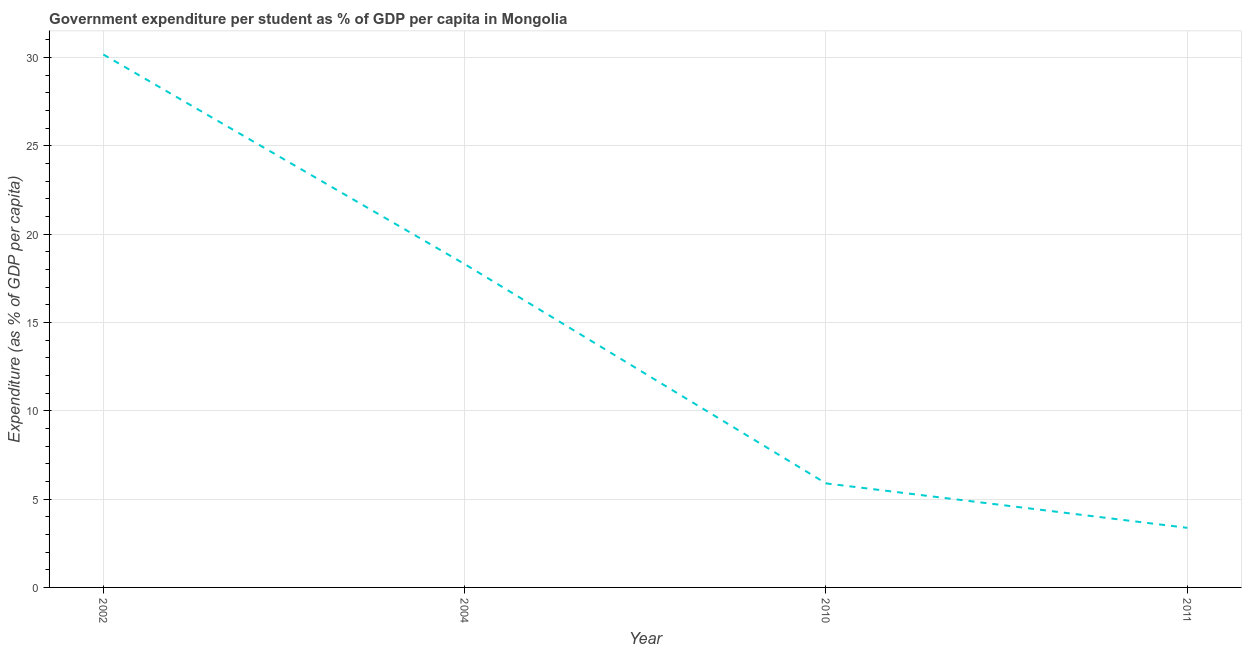What is the government expenditure per student in 2002?
Your answer should be very brief. 30.17. Across all years, what is the maximum government expenditure per student?
Offer a terse response. 30.17. Across all years, what is the minimum government expenditure per student?
Your answer should be very brief. 3.37. In which year was the government expenditure per student minimum?
Keep it short and to the point. 2011. What is the sum of the government expenditure per student?
Offer a terse response. 57.74. What is the difference between the government expenditure per student in 2002 and 2004?
Your answer should be very brief. 11.86. What is the average government expenditure per student per year?
Make the answer very short. 14.43. What is the median government expenditure per student?
Make the answer very short. 12.1. In how many years, is the government expenditure per student greater than 4 %?
Provide a short and direct response. 3. What is the ratio of the government expenditure per student in 2002 to that in 2004?
Offer a very short reply. 1.65. Is the government expenditure per student in 2002 less than that in 2011?
Your answer should be compact. No. Is the difference between the government expenditure per student in 2010 and 2011 greater than the difference between any two years?
Offer a terse response. No. What is the difference between the highest and the second highest government expenditure per student?
Provide a short and direct response. 11.86. What is the difference between the highest and the lowest government expenditure per student?
Offer a very short reply. 26.8. In how many years, is the government expenditure per student greater than the average government expenditure per student taken over all years?
Provide a succinct answer. 2. What is the difference between two consecutive major ticks on the Y-axis?
Provide a succinct answer. 5. Are the values on the major ticks of Y-axis written in scientific E-notation?
Give a very brief answer. No. What is the title of the graph?
Ensure brevity in your answer.  Government expenditure per student as % of GDP per capita in Mongolia. What is the label or title of the X-axis?
Provide a succinct answer. Year. What is the label or title of the Y-axis?
Give a very brief answer. Expenditure (as % of GDP per capita). What is the Expenditure (as % of GDP per capita) of 2002?
Offer a terse response. 30.17. What is the Expenditure (as % of GDP per capita) in 2004?
Your answer should be compact. 18.3. What is the Expenditure (as % of GDP per capita) of 2010?
Your response must be concise. 5.89. What is the Expenditure (as % of GDP per capita) of 2011?
Your answer should be compact. 3.37. What is the difference between the Expenditure (as % of GDP per capita) in 2002 and 2004?
Offer a terse response. 11.86. What is the difference between the Expenditure (as % of GDP per capita) in 2002 and 2010?
Make the answer very short. 24.28. What is the difference between the Expenditure (as % of GDP per capita) in 2002 and 2011?
Your response must be concise. 26.8. What is the difference between the Expenditure (as % of GDP per capita) in 2004 and 2010?
Give a very brief answer. 12.41. What is the difference between the Expenditure (as % of GDP per capita) in 2004 and 2011?
Offer a terse response. 14.93. What is the difference between the Expenditure (as % of GDP per capita) in 2010 and 2011?
Ensure brevity in your answer.  2.52. What is the ratio of the Expenditure (as % of GDP per capita) in 2002 to that in 2004?
Offer a terse response. 1.65. What is the ratio of the Expenditure (as % of GDP per capita) in 2002 to that in 2010?
Your answer should be very brief. 5.12. What is the ratio of the Expenditure (as % of GDP per capita) in 2002 to that in 2011?
Your answer should be compact. 8.95. What is the ratio of the Expenditure (as % of GDP per capita) in 2004 to that in 2010?
Give a very brief answer. 3.11. What is the ratio of the Expenditure (as % of GDP per capita) in 2004 to that in 2011?
Your response must be concise. 5.43. What is the ratio of the Expenditure (as % of GDP per capita) in 2010 to that in 2011?
Keep it short and to the point. 1.75. 